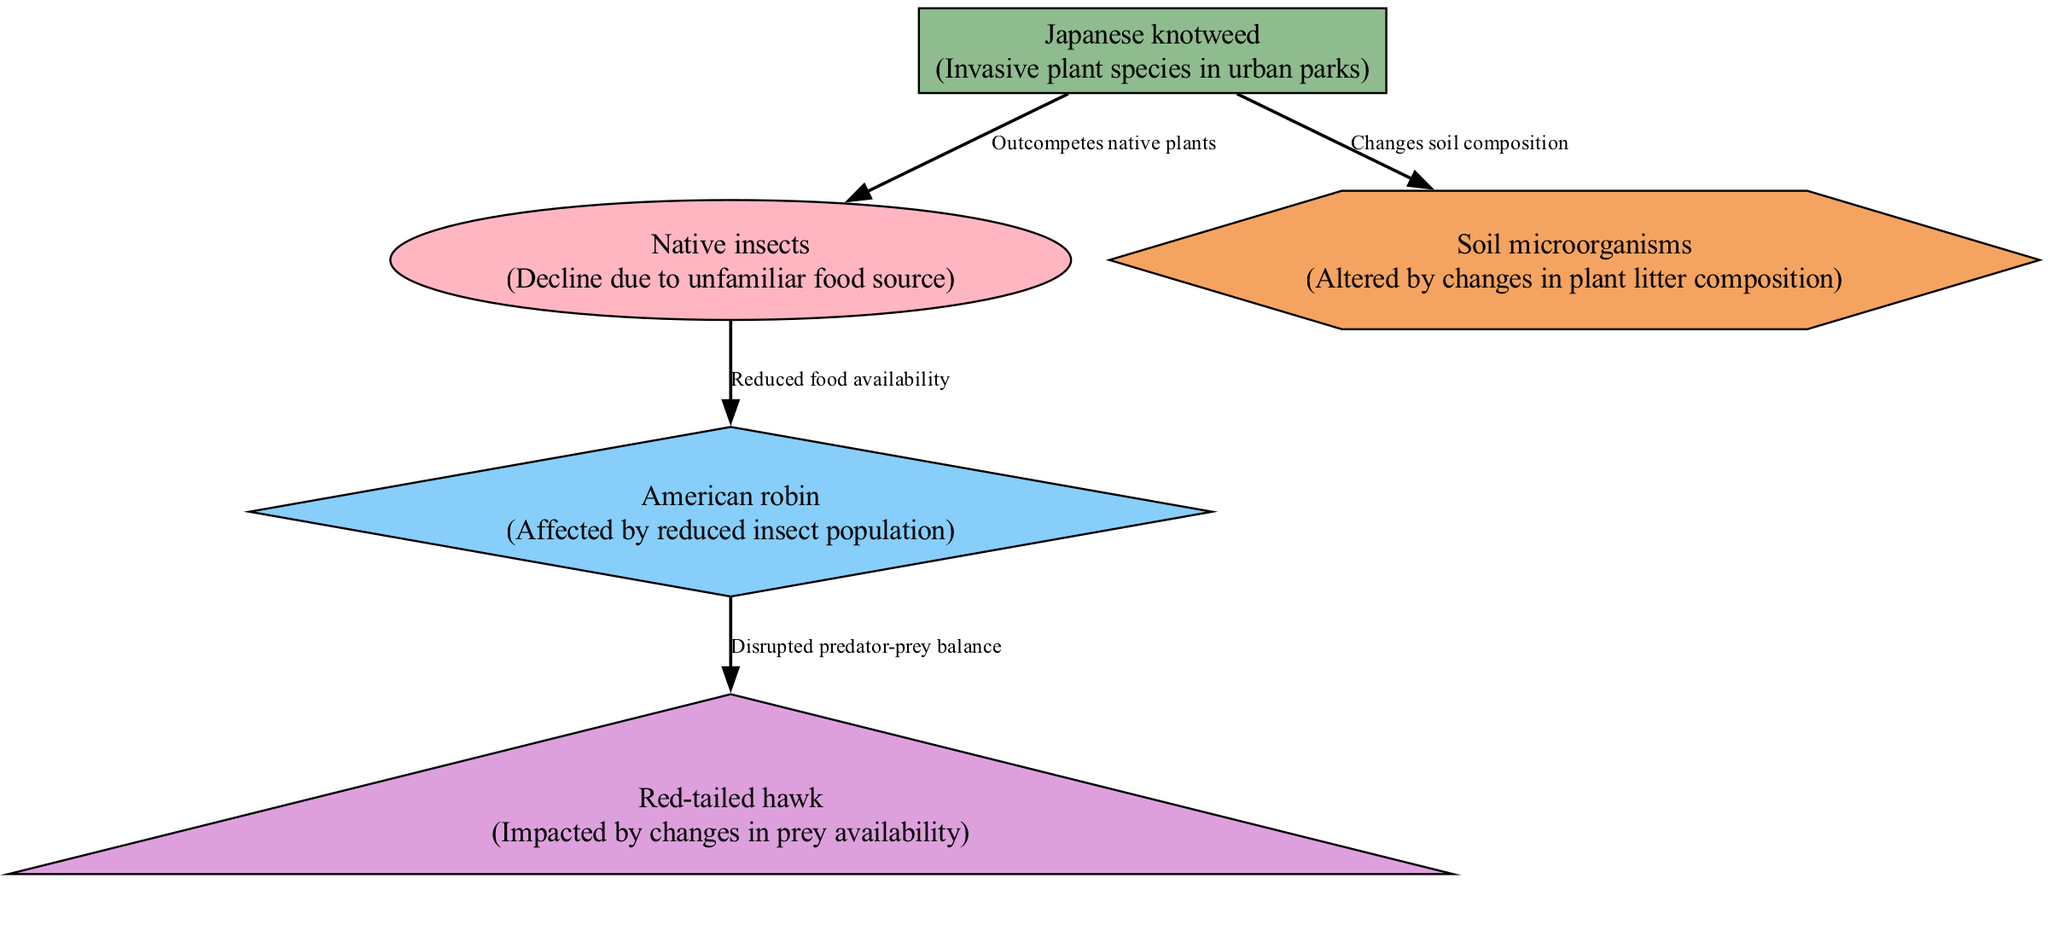What is the primary producer in this food chain? The primary producer shown in the diagram is "Japanese knotweed," which is identified as the invasive plant species that starts the food chain.
Answer: Japanese knotweed How many total nodes are in the diagram? To find the total number of nodes, we count all the elements classified as producers, consumers (primary, secondary, tertiary), and decomposers. There are five nodes: Japanese knotweed, Native insects, American robin, Red-tailed hawk, and Soil microorganisms.
Answer: 5 What impact does Japanese knotweed have on native insects? The diagram specifies that Japanese knotweed outcompetes native plants, which leads to a decline in native insects due to unfamiliar food sources.
Answer: Outcompetes native plants What is the relationship between American robin and Red-tailed hawk? The diagram indicates a disrupted predator-prey balance between American robin and Red-tailed hawk, meaning that the American robin's decreased population affects the availability of food for the Red-tailed hawk.
Answer: Disrupted predator-prey balance What type of consumer is the American robin? In the diagram, the American robin is classified as a secondary consumer, as it preys on primary consumers, specifically native insects.
Answer: Secondary consumer 